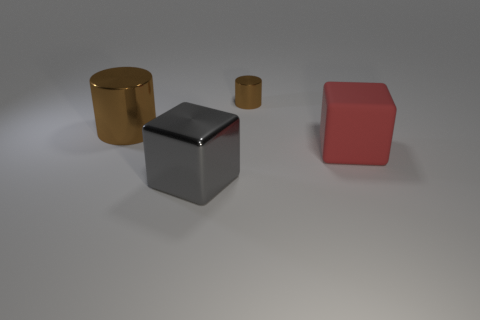What is the size of the cube behind the metal cube?
Your answer should be very brief. Large. What is the shape of the object that is both behind the rubber block and on the right side of the big gray thing?
Offer a very short reply. Cylinder. What is the size of the red thing that is the same shape as the gray shiny thing?
Your response must be concise. Large. How many brown things have the same material as the big cylinder?
Offer a very short reply. 1. There is a tiny cylinder; is its color the same as the big thing that is behind the big red rubber thing?
Your answer should be very brief. Yes. Are there more tiny cylinders than big purple spheres?
Ensure brevity in your answer.  Yes. What color is the metallic block?
Ensure brevity in your answer.  Gray. Is the color of the tiny metallic cylinder behind the big brown metallic thing the same as the big cylinder?
Your response must be concise. Yes. There is a large cylinder that is the same color as the small metal cylinder; what is its material?
Provide a succinct answer. Metal. What number of large metallic cylinders have the same color as the small shiny cylinder?
Provide a short and direct response. 1. 